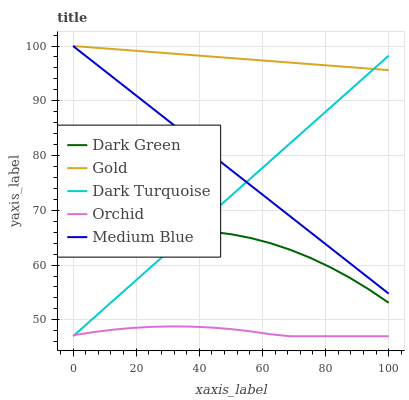Does Orchid have the minimum area under the curve?
Answer yes or no. Yes. Does Gold have the maximum area under the curve?
Answer yes or no. Yes. Does Medium Blue have the minimum area under the curve?
Answer yes or no. No. Does Medium Blue have the maximum area under the curve?
Answer yes or no. No. Is Dark Turquoise the smoothest?
Answer yes or no. Yes. Is Dark Green the roughest?
Answer yes or no. Yes. Is Orchid the smoothest?
Answer yes or no. No. Is Orchid the roughest?
Answer yes or no. No. Does Dark Turquoise have the lowest value?
Answer yes or no. Yes. Does Medium Blue have the lowest value?
Answer yes or no. No. Does Gold have the highest value?
Answer yes or no. Yes. Does Orchid have the highest value?
Answer yes or no. No. Is Orchid less than Dark Green?
Answer yes or no. Yes. Is Gold greater than Orchid?
Answer yes or no. Yes. Does Dark Turquoise intersect Orchid?
Answer yes or no. Yes. Is Dark Turquoise less than Orchid?
Answer yes or no. No. Is Dark Turquoise greater than Orchid?
Answer yes or no. No. Does Orchid intersect Dark Green?
Answer yes or no. No. 